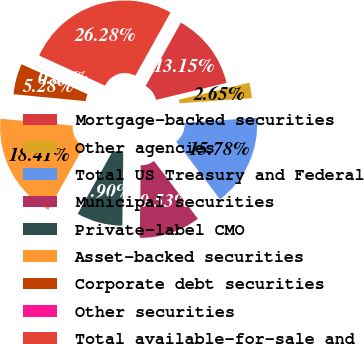Convert chart. <chart><loc_0><loc_0><loc_500><loc_500><pie_chart><fcel>Mortgage-backed securities<fcel>Other agencies<fcel>Total US Treasury and Federal<fcel>Municipal securities<fcel>Private-label CMO<fcel>Asset-backed securities<fcel>Corporate debt securities<fcel>Other securities<fcel>Total available-for-sale and<nl><fcel>13.15%<fcel>2.65%<fcel>15.78%<fcel>10.53%<fcel>7.9%<fcel>18.41%<fcel>5.28%<fcel>0.02%<fcel>26.28%<nl></chart> 